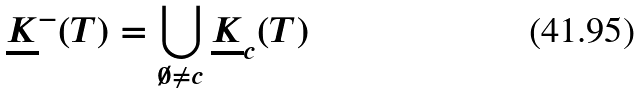<formula> <loc_0><loc_0><loc_500><loc_500>\underline { K } ^ { - } ( T ) = \bigcup _ { \emptyset \not = c } \underline { K } _ { c } ( T )</formula> 